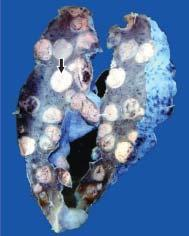what are replaced by multiple, variable-sized, circumscribed nodular masses which are grey-white in colour?
Answer the question using a single word or phrase. Large parts of the lung parenchyma 